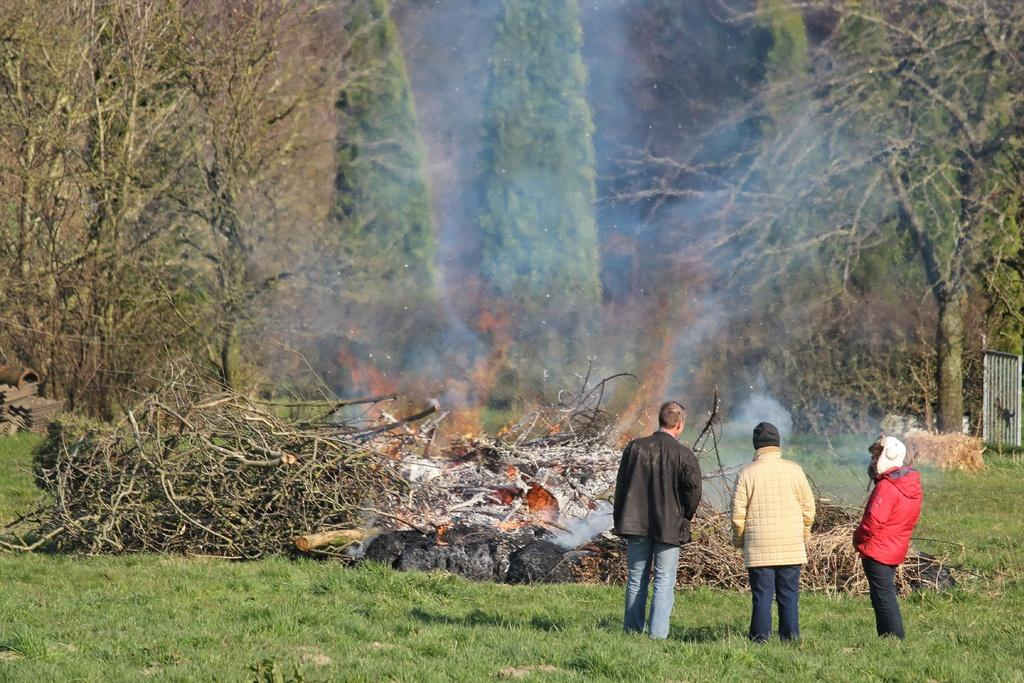What is the setting of the image? The setting of the image is on grassland. What are the people doing in the image? The people are standing on the grassland. What can be seen in the background of the image? Trees are visible in the background. What is on the right side of the image? There is a fence on the right side of the image. What type of air is being taught in the image? There is no teaching or air present in the image; it features people standing on grassland with trees in the background and a fence on the right side. How many bananas can be seen in the image? There are no bananas present in the image. 